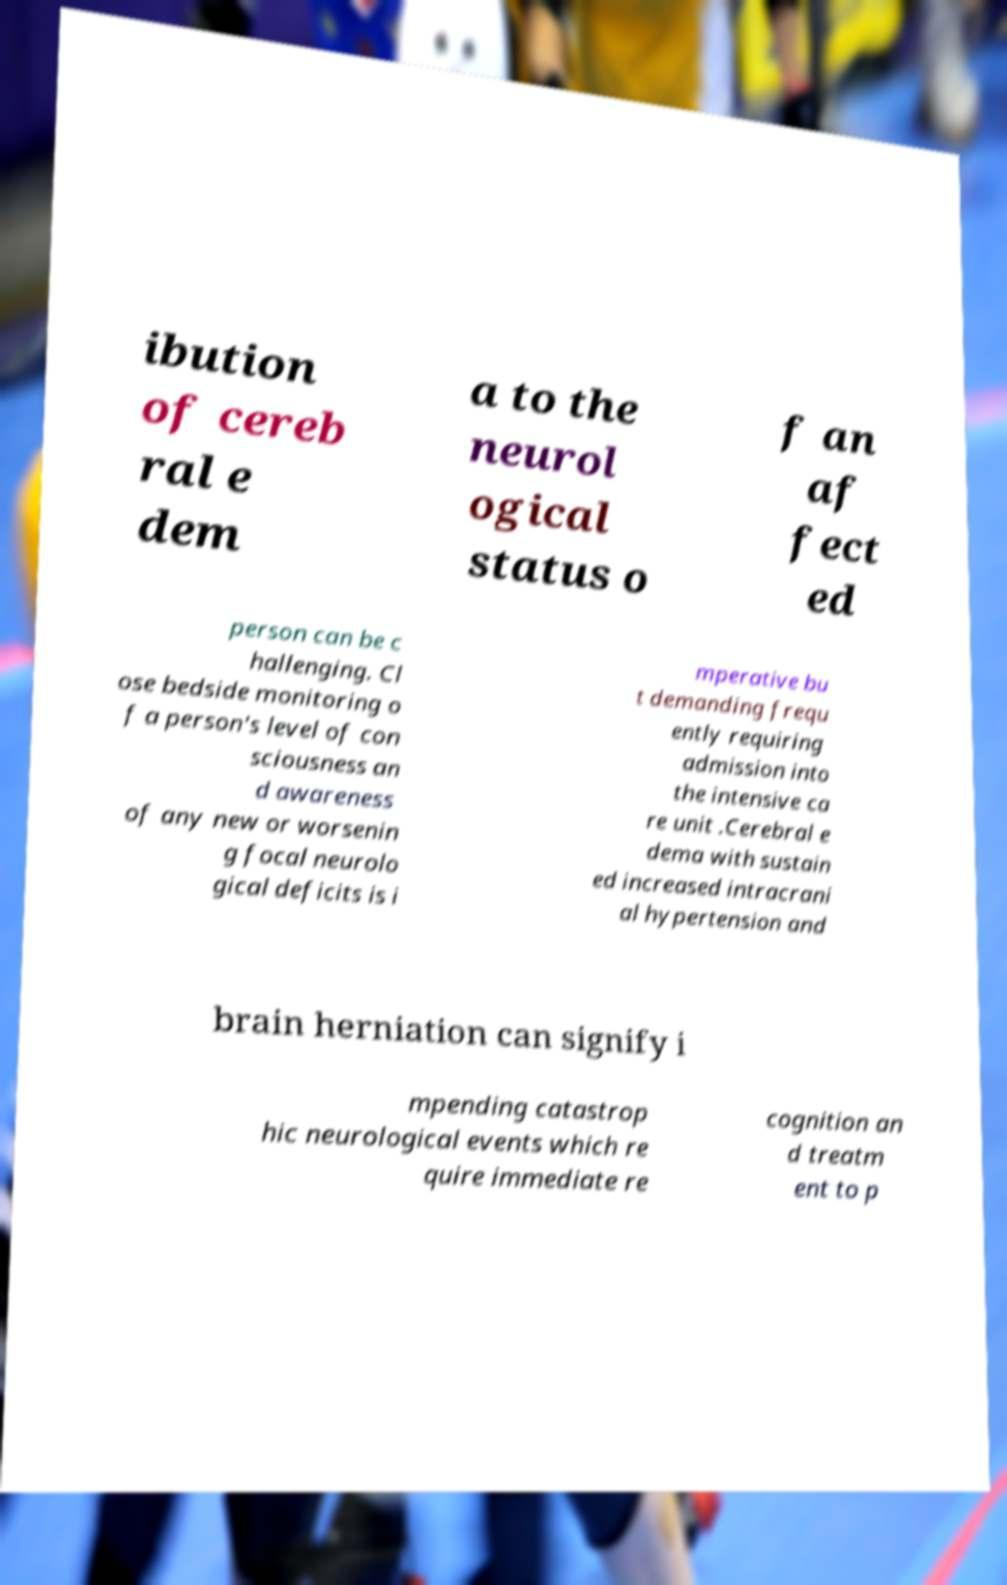There's text embedded in this image that I need extracted. Can you transcribe it verbatim? ibution of cereb ral e dem a to the neurol ogical status o f an af fect ed person can be c hallenging. Cl ose bedside monitoring o f a person's level of con sciousness an d awareness of any new or worsenin g focal neurolo gical deficits is i mperative bu t demanding frequ ently requiring admission into the intensive ca re unit .Cerebral e dema with sustain ed increased intracrani al hypertension and brain herniation can signify i mpending catastrop hic neurological events which re quire immediate re cognition an d treatm ent to p 